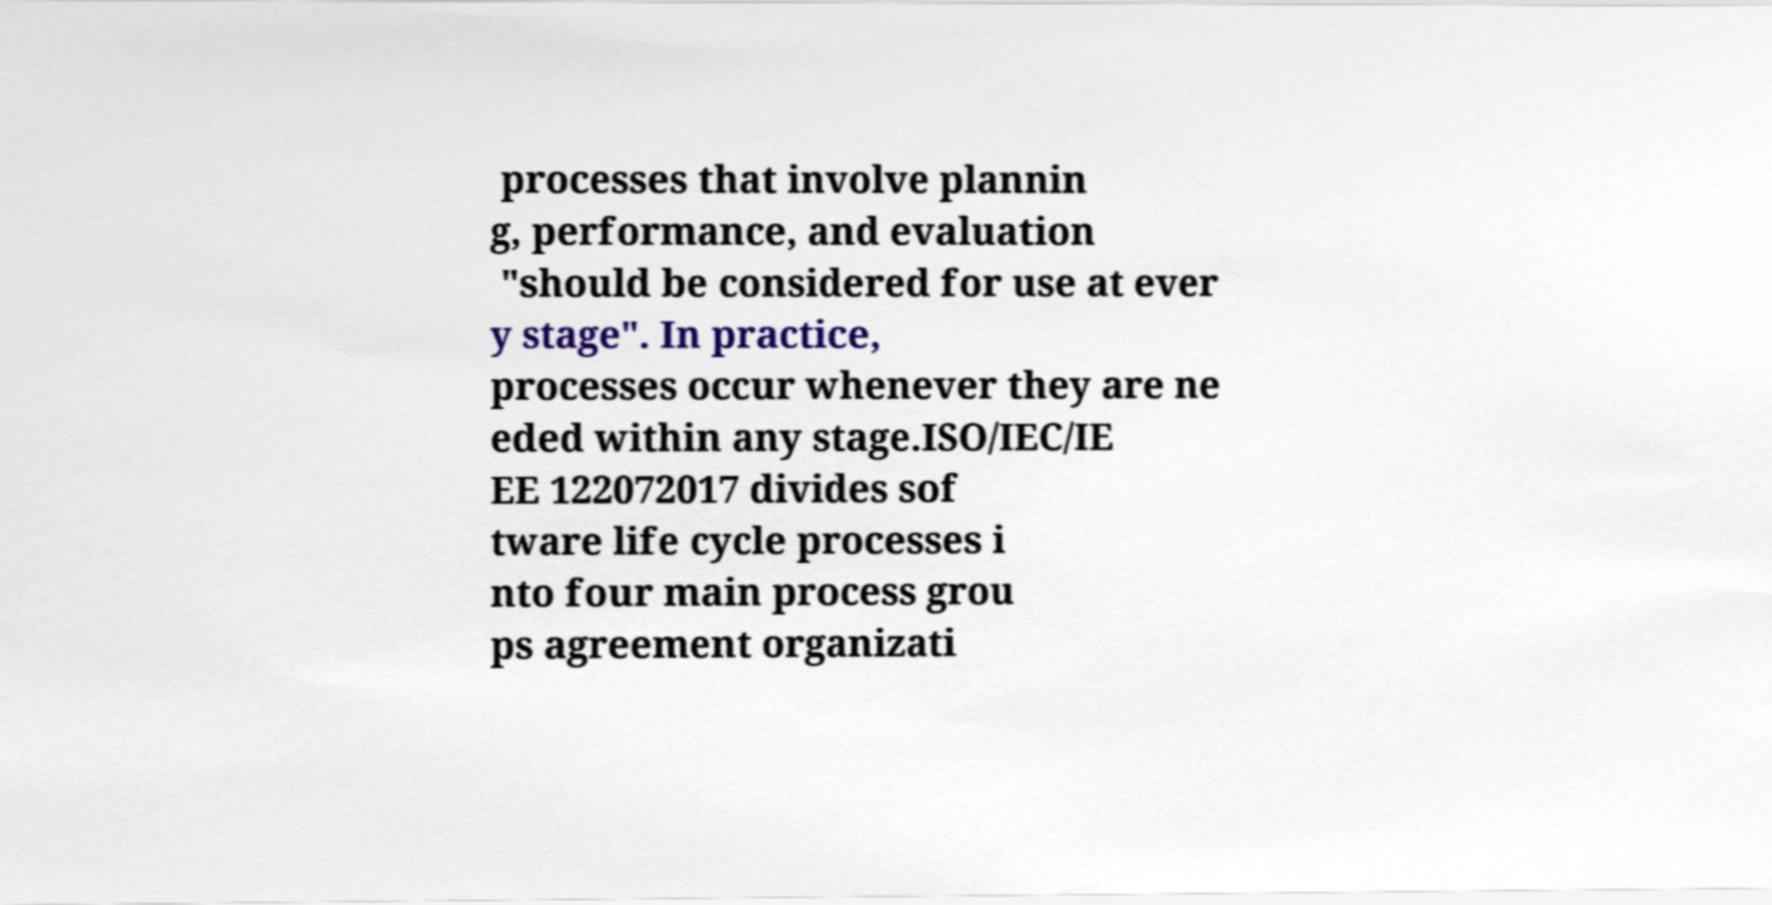I need the written content from this picture converted into text. Can you do that? processes that involve plannin g, performance, and evaluation "should be considered for use at ever y stage". In practice, processes occur whenever they are ne eded within any stage.ISO/IEC/IE EE 122072017 divides sof tware life cycle processes i nto four main process grou ps agreement organizati 